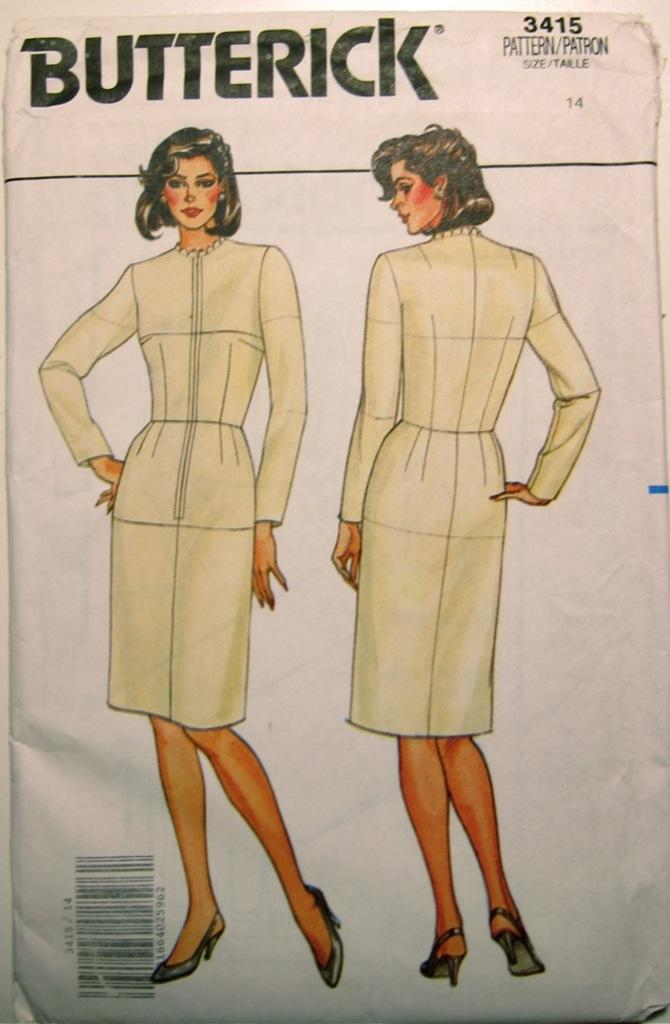What is present in the image? There is a poster in the image. What is depicted on the poster? The poster features a girl. Are there any birds visible in the prison depicted on the poster? There is no prison or birds present in the image; it features a poster with a girl. What type of chalk is being used by the girl in the image? There is no chalk or indication of the girl using chalk in the image; it only features her on the poster. 